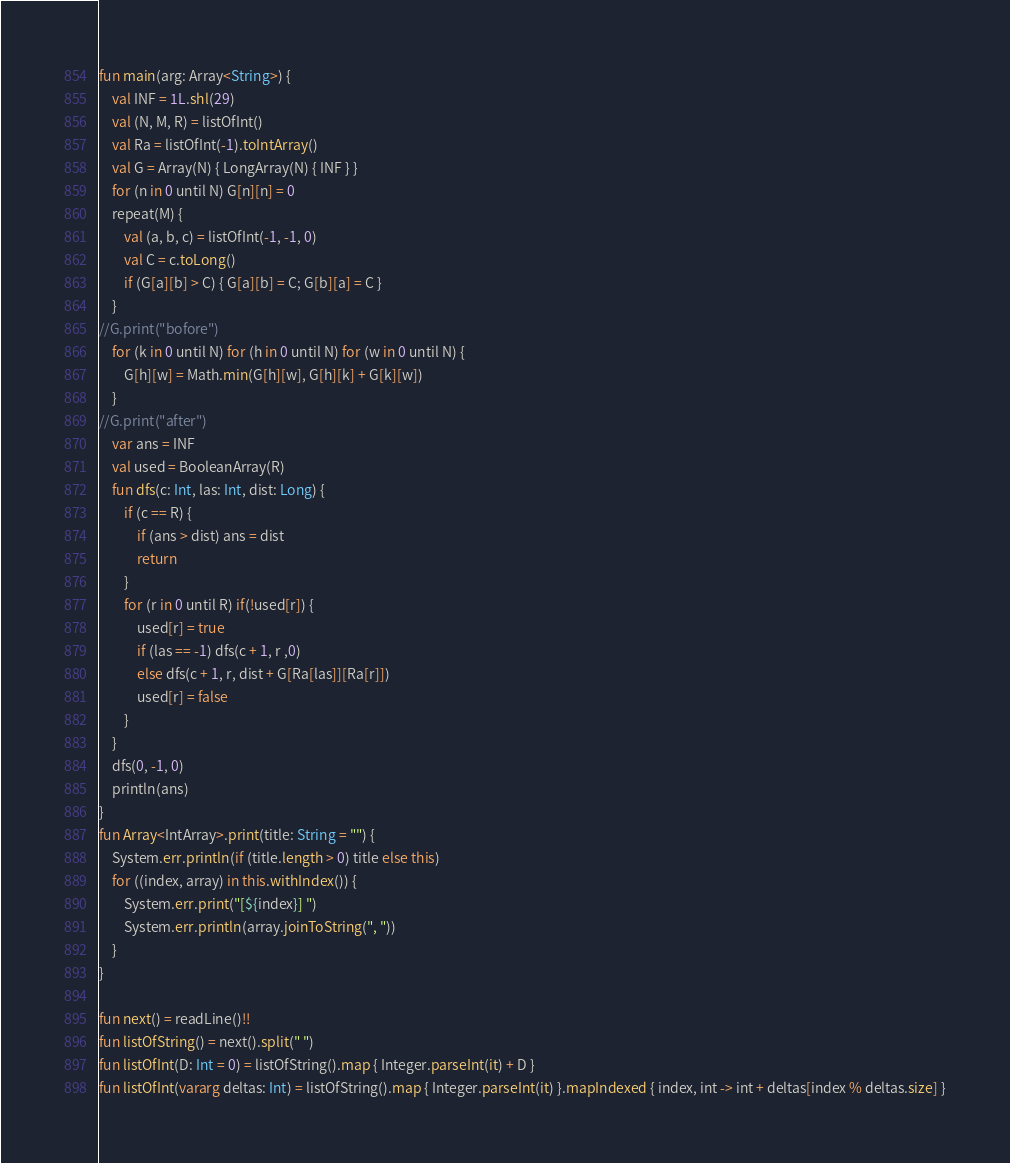<code> <loc_0><loc_0><loc_500><loc_500><_Kotlin_>fun main(arg: Array<String>) {
    val INF = 1L.shl(29)
    val (N, M, R) = listOfInt()
    val Ra = listOfInt(-1).toIntArray()
    val G = Array(N) { LongArray(N) { INF } }
    for (n in 0 until N) G[n][n] = 0
    repeat(M) {
        val (a, b, c) = listOfInt(-1, -1, 0)
        val C = c.toLong()
        if (G[a][b] > C) { G[a][b] = C; G[b][a] = C }
    }
//G.print("bofore")
    for (k in 0 until N) for (h in 0 until N) for (w in 0 until N) {
        G[h][w] = Math.min(G[h][w], G[h][k] + G[k][w])
    }
//G.print("after")
    var ans = INF
    val used = BooleanArray(R)
    fun dfs(c: Int, las: Int, dist: Long) {
        if (c == R) {
            if (ans > dist) ans = dist
            return
        }
        for (r in 0 until R) if(!used[r]) {
            used[r] = true
            if (las == -1) dfs(c + 1, r ,0)
            else dfs(c + 1, r, dist + G[Ra[las]][Ra[r]])
            used[r] = false
        }
    }
    dfs(0, -1, 0)
    println(ans)
}
fun Array<IntArray>.print(title: String = "") {
    System.err.println(if (title.length > 0) title else this)
    for ((index, array) in this.withIndex()) {
        System.err.print("[${index}] ")
        System.err.println(array.joinToString(", "))
    }
}

fun next() = readLine()!!
fun listOfString() = next().split(" ")
fun listOfInt(D: Int = 0) = listOfString().map { Integer.parseInt(it) + D }
fun listOfInt(vararg deltas: Int) = listOfString().map { Integer.parseInt(it) }.mapIndexed { index, int -> int + deltas[index % deltas.size] }
</code> 